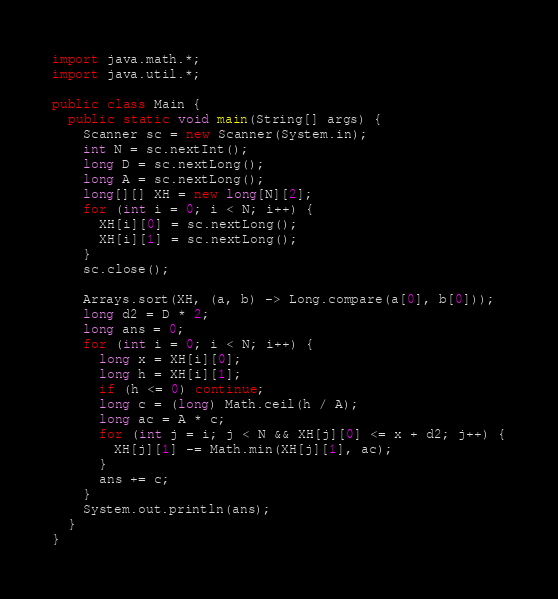Convert code to text. <code><loc_0><loc_0><loc_500><loc_500><_Java_>import java.math.*;
import java.util.*;
 
public class Main {
  public static void main(String[] args) {
    Scanner sc = new Scanner(System.in);
    int N = sc.nextInt();
    long D = sc.nextLong();
    long A = sc.nextLong();
    long[][] XH = new long[N][2];
    for (int i = 0; i < N; i++) {
      XH[i][0] = sc.nextLong();
      XH[i][1] = sc.nextLong();
    }
    sc.close();

    Arrays.sort(XH, (a, b) -> Long.compare(a[0], b[0]));
    long d2 = D * 2;
    long ans = 0;
    for (int i = 0; i < N; i++) {
      long x = XH[i][0];
      long h = XH[i][1];
      if (h <= 0) continue;
      long c = (long) Math.ceil(h / A);
      long ac = A * c;
      for (int j = i; j < N && XH[j][0] <= x + d2; j++) {
        XH[j][1] -= Math.min(XH[j][1], ac);
      }
      ans += c;
    }
    System.out.println(ans);
  }
}</code> 